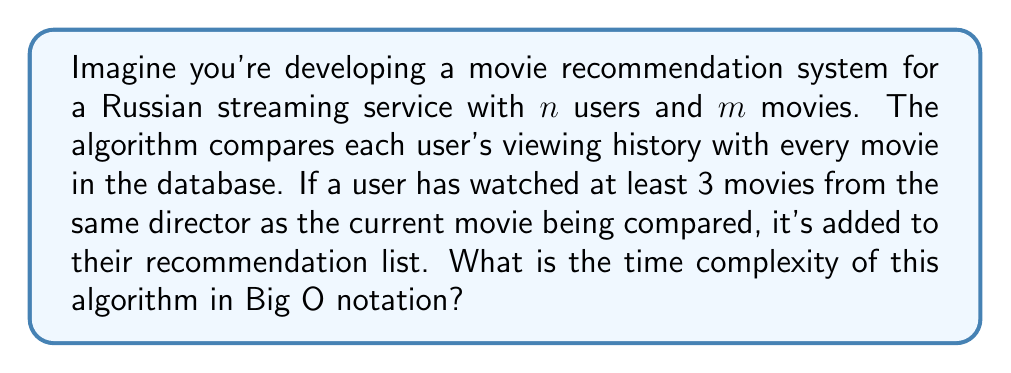Provide a solution to this math problem. Let's break down the algorithm and analyze its time complexity:

1. For each user ($n$ iterations):
   a. We need to compare their viewing history with every movie in the database ($m$ iterations).
   b. For each comparison, we need to check if the user has watched at least 3 movies from the same director.

2. Let's assume that checking a user's viewing history for movies by the same director takes constant time $O(1)$ (this could be achieved with proper data structuring).

3. The nested loop structure gives us:
   $$ n \times m \times O(1) = O(nm) $$

4. This means that the time complexity grows linearly with both the number of users and the number of movies.

5. In Big O notation, we express this as $O(nm)$, which represents the upper bound of the algorithm's running time.

6. It's worth noting that this algorithm might not be the most efficient for large datasets. For a production recommendation system, you might want to consider more advanced techniques like collaborative filtering or matrix factorization, which could potentially offer better performance.
Answer: $O(nm)$ 